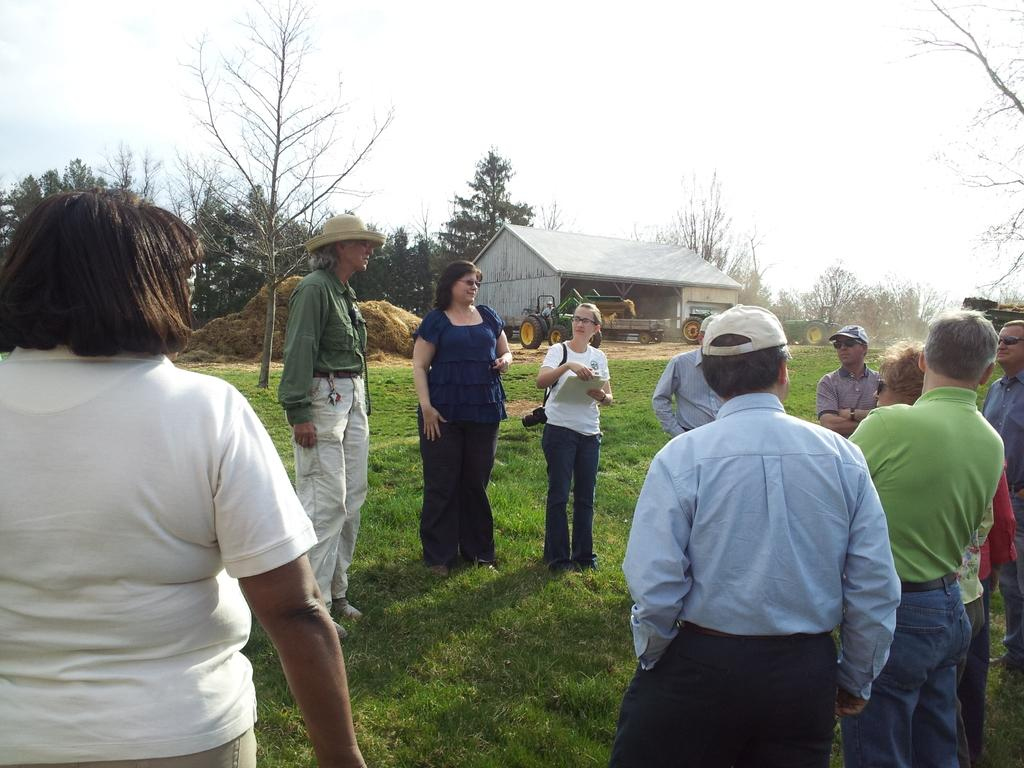How many people can be seen in the image? There are people standing in the image. What is one person doing in the image? One person is carrying a camera. What is another person holding in the image? One person is holding an object. What type of natural environment is visible in the image? There is grass visible in the image, and trees are in the background. What additional features can be seen in the background of the image? There is dried grass, a shed, vehicles, and another person in the background. What can be seen in the sky in the image? The sky is visible in the background of the image. What type of church can be seen in the background of the image? There is no church present in the image; only a shed and other objects can be seen in the background. 